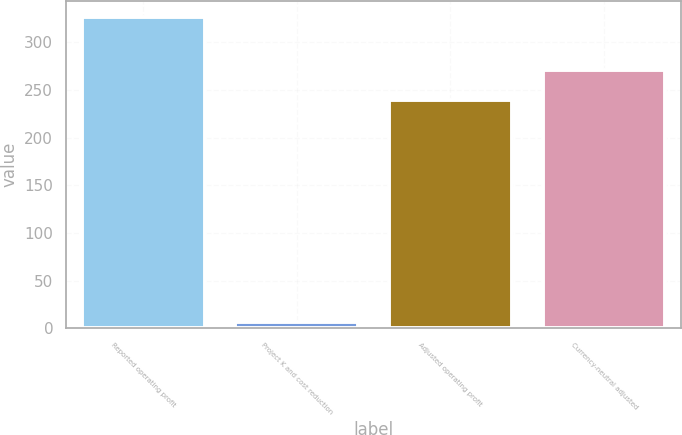<chart> <loc_0><loc_0><loc_500><loc_500><bar_chart><fcel>Reported operating profit<fcel>Project K and cost reduction<fcel>Adjusted operating profit<fcel>Currency-neutral adjusted<nl><fcel>327<fcel>7<fcel>239<fcel>271<nl></chart> 